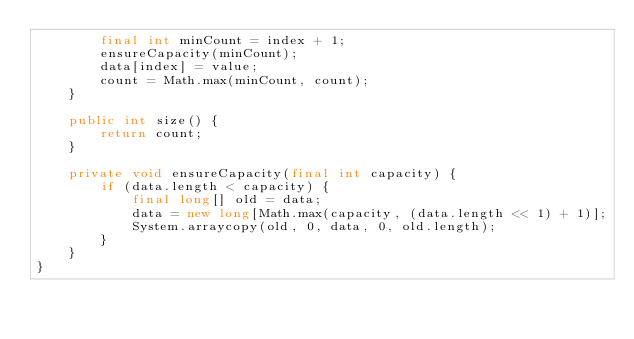<code> <loc_0><loc_0><loc_500><loc_500><_Java_>        final int minCount = index + 1;
        ensureCapacity(minCount);
        data[index] = value;
        count = Math.max(minCount, count);
    }

    public int size() {
        return count;
    }

    private void ensureCapacity(final int capacity) {
        if (data.length < capacity) {
            final long[] old = data;
            data = new long[Math.max(capacity, (data.length << 1) + 1)];
            System.arraycopy(old, 0, data, 0, old.length);
        }
    }
}
</code> 